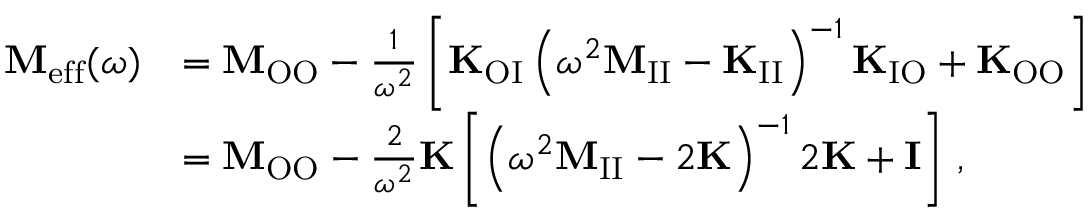<formula> <loc_0><loc_0><loc_500><loc_500>\begin{array} { r l } { M _ { e f f } ( \omega ) } & { = M _ { O O } - \frac { 1 } { \omega ^ { 2 } } \left [ K _ { O I } \left ( \omega ^ { 2 } M _ { I I } - K _ { I I } \right ) ^ { - 1 } K _ { I O } + K _ { O O } \right ] } \\ & { = M _ { O O } - \frac { 2 } { \omega ^ { 2 } } K \left [ \left ( \omega ^ { 2 } M _ { I I } - 2 K \right ) ^ { - 1 } 2 K + I \right ] \, , } \end{array}</formula> 